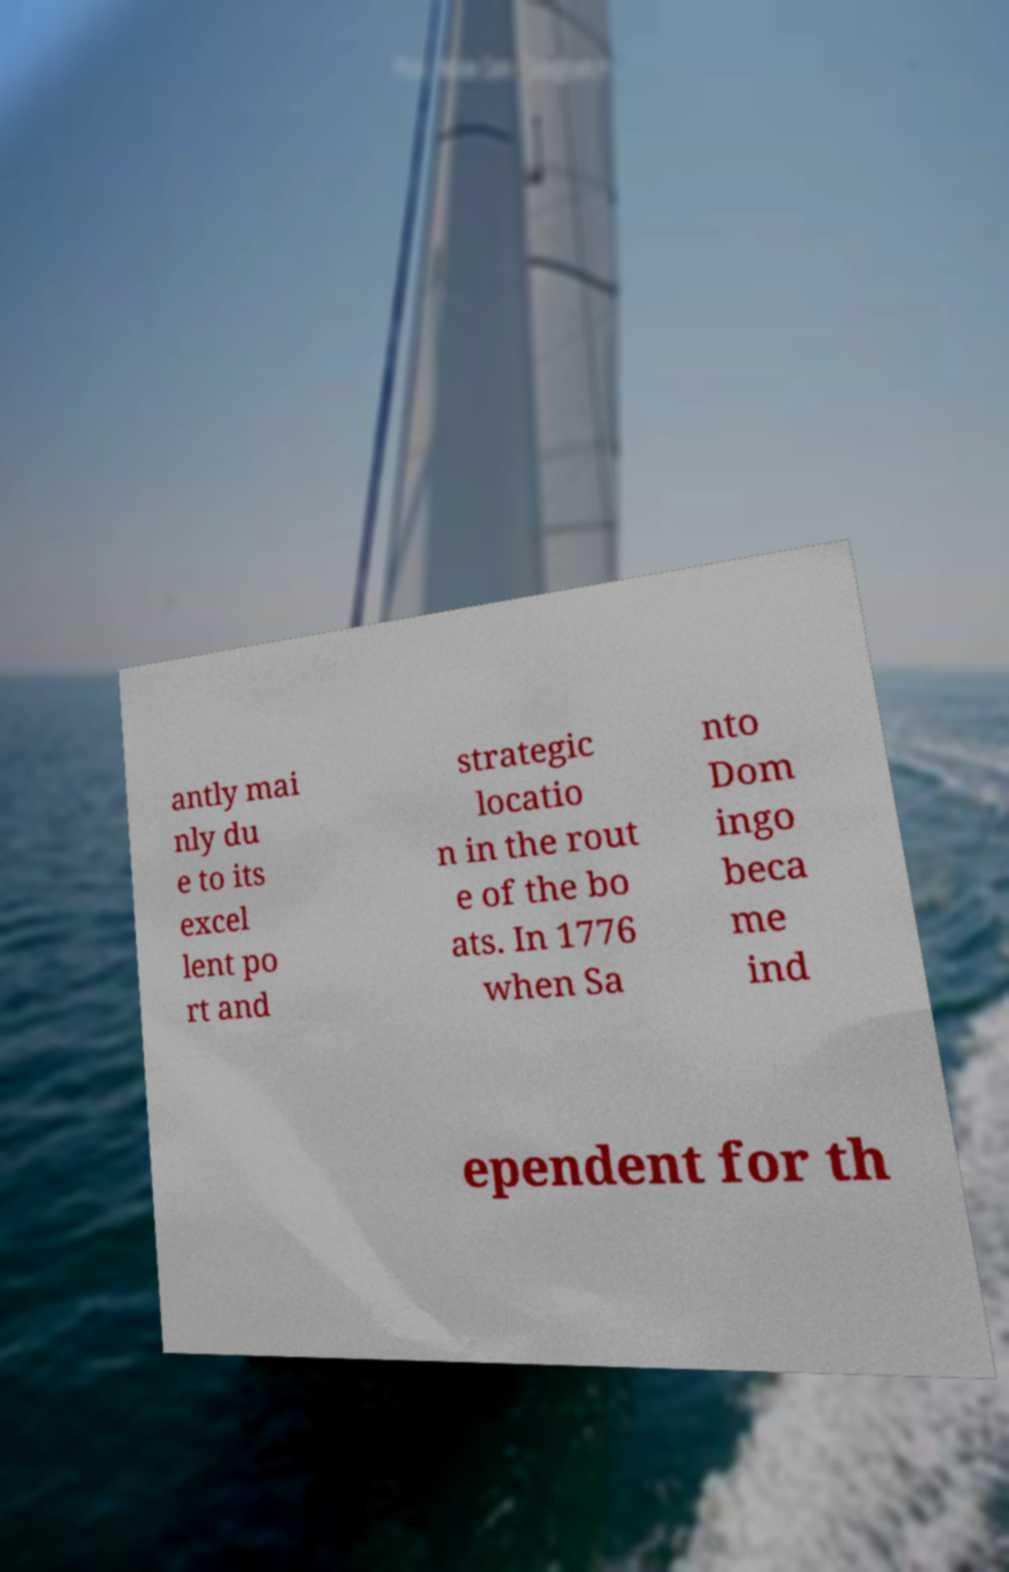Can you accurately transcribe the text from the provided image for me? antly mai nly du e to its excel lent po rt and strategic locatio n in the rout e of the bo ats. In 1776 when Sa nto Dom ingo beca me ind ependent for th 